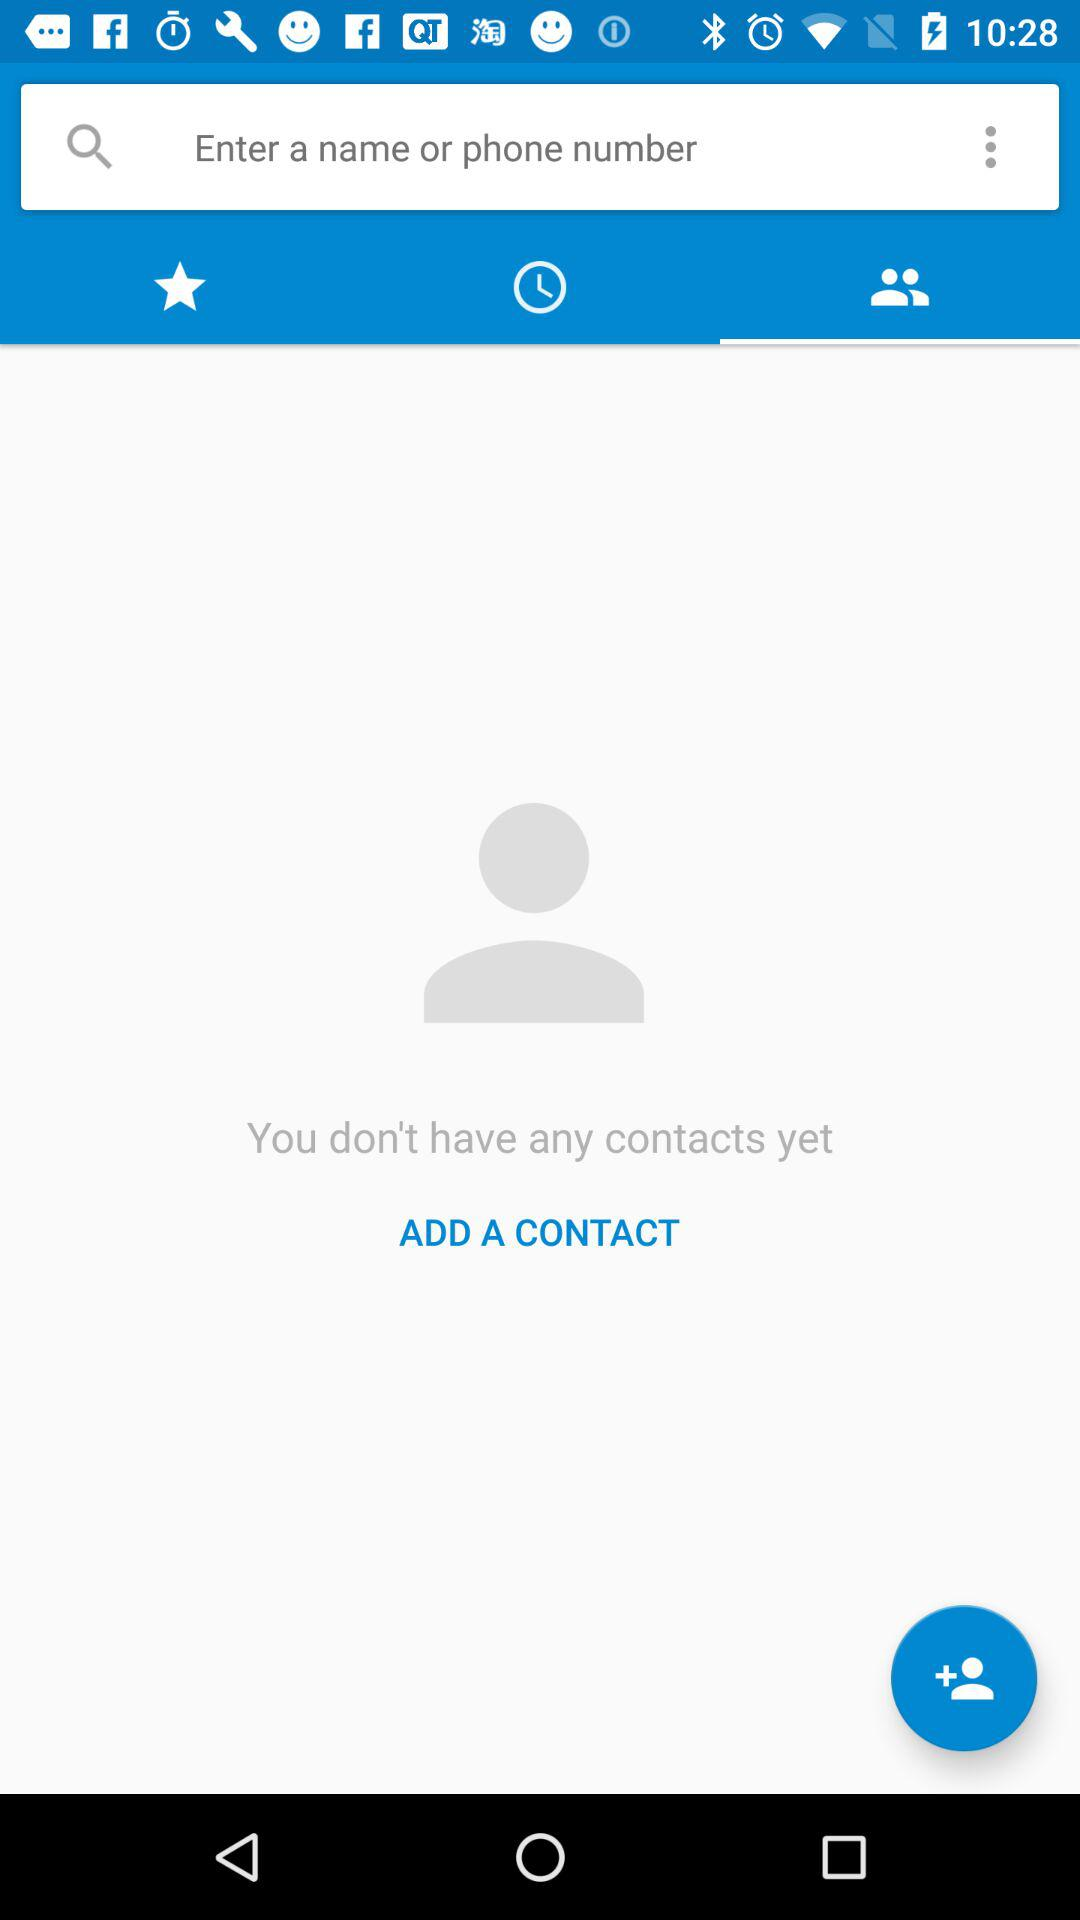How many contacts are there? There are no contacts yet. 